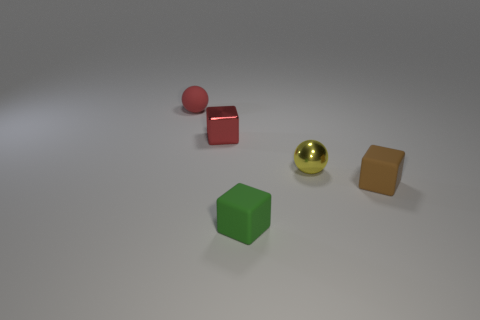What number of things are either tiny matte blocks or small metal cubes?
Your answer should be compact. 3. Are there any other things of the same color as the metallic block?
Provide a short and direct response. Yes. Do the tiny green object and the small cube that is behind the brown block have the same material?
Ensure brevity in your answer.  No. What shape is the red object to the left of the tiny red thing that is right of the small rubber sphere?
Your response must be concise. Sphere. What is the shape of the tiny thing that is right of the red rubber thing and behind the small yellow ball?
Offer a terse response. Cube. What number of objects are brown things or shiny things that are in front of the shiny block?
Your response must be concise. 2. There is another thing that is the same shape as the small red rubber object; what is its material?
Your response must be concise. Metal. Is there anything else that has the same material as the red ball?
Your answer should be compact. Yes. The small thing that is both left of the tiny yellow ball and in front of the yellow thing is made of what material?
Provide a succinct answer. Rubber. What number of tiny yellow metal things have the same shape as the tiny brown matte thing?
Make the answer very short. 0. 